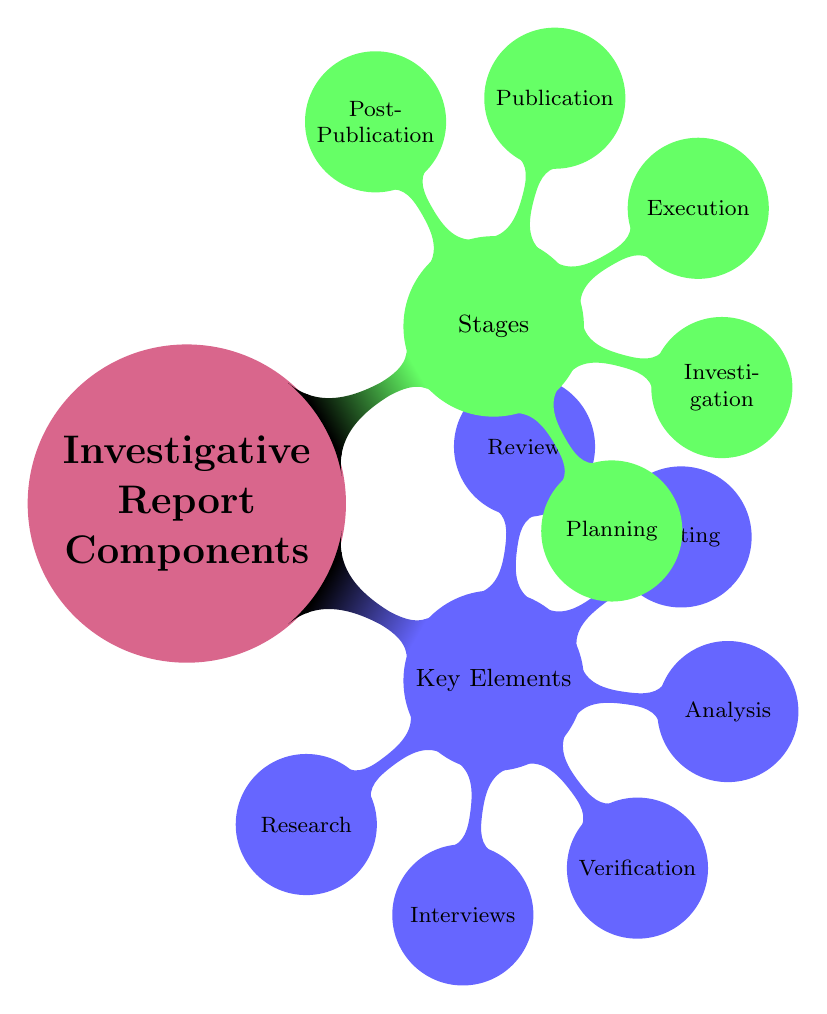What are the two main categories of components in an investigative report? The mind map clearly shows that the two main categories are "Key Elements" and "Stages." These are the primary divisions under the main topic "Investigative Report Components."
Answer: Key Elements and Stages How many nodes are there under "Key Elements"? By examining the diagram, I can count that there are six nodes under "Key Elements," which include Research, Interviews, Verification, Analysis, Writing, and Review.
Answer: 6 What is the last stage in the investigative report process? Looking at the "Stages" section of the mind map, the last stage listed is "Post-Publication." This indicates the final part of the investigative report process.
Answer: Post-Publication Which key element comes after "Verification" in the diagram? The diagram indicates that after "Verification," the next key element listed is "Analysis." This follows the sequence of key elements as depicted.
Answer: Analysis How many components are listed under "Interviews"? In the mind map, there are three components listed under "Interviews," specifically Primary Sources, Secondary Sources, and Expert Testimonies.
Answer: 3 What stage includes "Field Research"? The mind map shows that "Field Research" is included in the "Investigation" stage. This is part of the process in gathering information.
Answer: Investigation Name one component of the "Review" key element. Upon inspecting the "Review" key element section in the mind map, one of the components is "Legal Review." This is one of the crucial aspects included.
Answer: Legal Review What comes before "Execution" in the sequence of stages? By reviewing the sequence of stages in the diagram, I find that "Investigation" comes directly before "Execution." This indicates the order of the investigative reporting process.
Answer: Investigation In total, how many elements comprise the "Writing" key element? The "Writing" key element in the mind map includes three specific components: Narrative Structure, Supporting Evidence, and Source Attribution; therefore, the total is three elements.
Answer: 3 